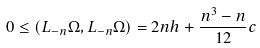Convert formula to latex. <formula><loc_0><loc_0><loc_500><loc_500>0 \leq ( L _ { - n } \Omega , L _ { - n } \Omega ) = 2 n h + \frac { n ^ { 3 } - n } { 1 2 } c</formula> 